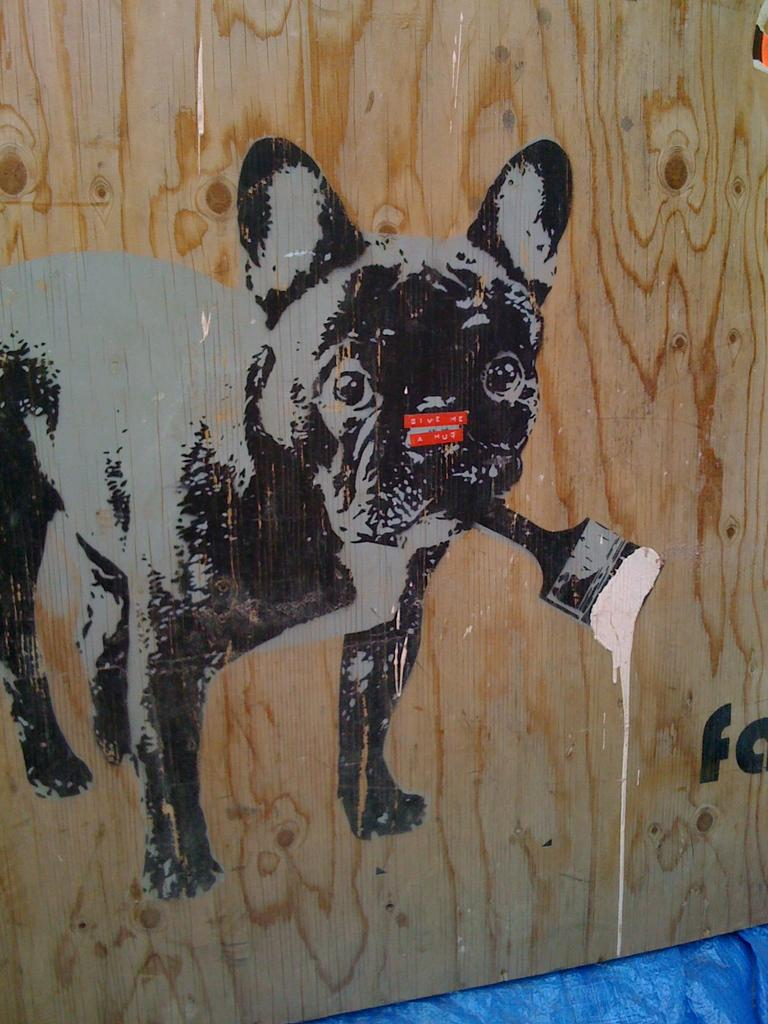What is depicted on the wooden sheet in the image? There is an art piece on a wooden sheet. What is the main subject of the art piece? The art piece contains a dog. What is the dog doing in the art piece? The dog is holding a brush in the art piece. What type of spoon is being used by the dog in the art piece? There is no spoon present in the art piece; the dog is holding a brush. 